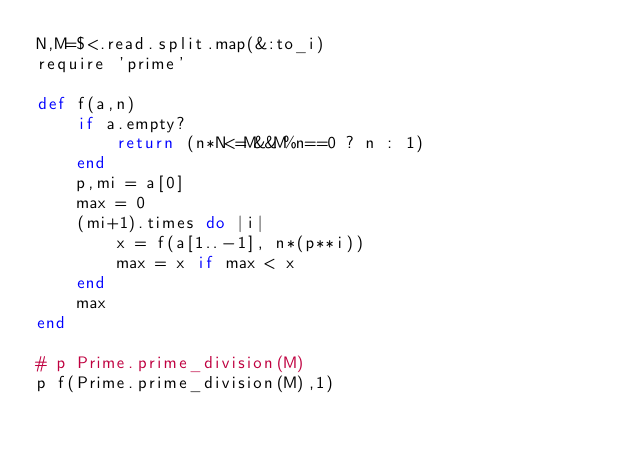Convert code to text. <code><loc_0><loc_0><loc_500><loc_500><_Ruby_>N,M=$<.read.split.map(&:to_i)
require 'prime'

def f(a,n)
    if a.empty?
        return (n*N<=M&&M%n==0 ? n : 1)
    end
    p,mi = a[0]
    max = 0
    (mi+1).times do |i|
        x = f(a[1..-1], n*(p**i))
        max = x if max < x
    end
    max
end

# p Prime.prime_division(M)
p f(Prime.prime_division(M),1)

</code> 